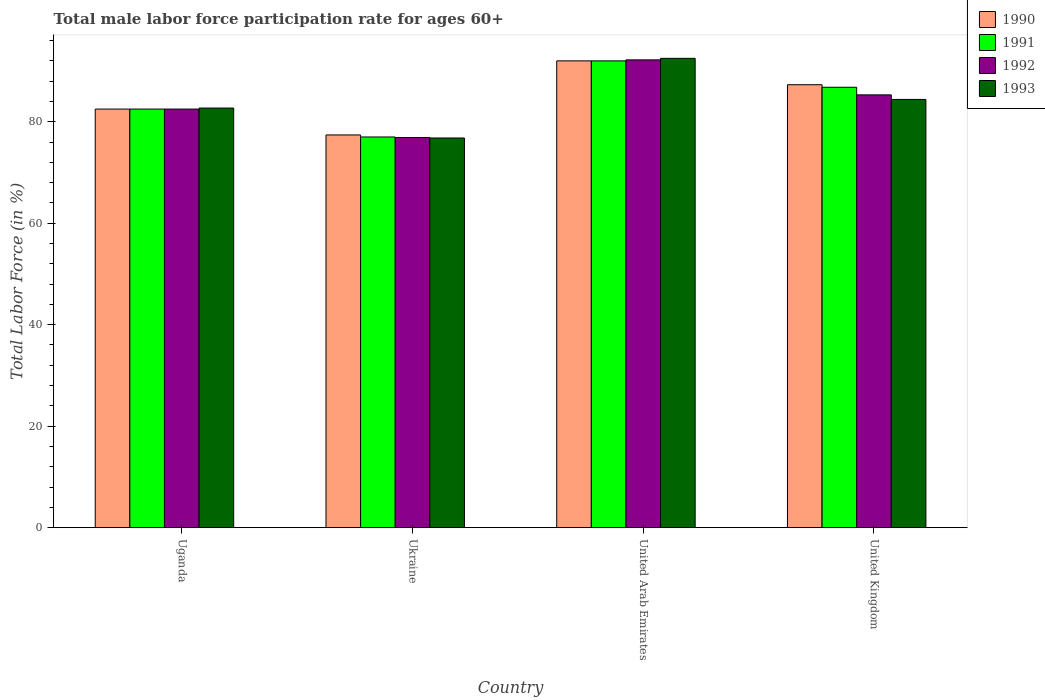How many different coloured bars are there?
Your answer should be very brief. 4. How many groups of bars are there?
Make the answer very short. 4. Are the number of bars per tick equal to the number of legend labels?
Your response must be concise. Yes. Are the number of bars on each tick of the X-axis equal?
Keep it short and to the point. Yes. How many bars are there on the 1st tick from the left?
Offer a terse response. 4. What is the label of the 2nd group of bars from the left?
Offer a terse response. Ukraine. What is the male labor force participation rate in 1992 in United Kingdom?
Your answer should be compact. 85.3. Across all countries, what is the maximum male labor force participation rate in 1992?
Make the answer very short. 92.2. Across all countries, what is the minimum male labor force participation rate in 1992?
Keep it short and to the point. 76.9. In which country was the male labor force participation rate in 1993 maximum?
Ensure brevity in your answer.  United Arab Emirates. In which country was the male labor force participation rate in 1991 minimum?
Ensure brevity in your answer.  Ukraine. What is the total male labor force participation rate in 1992 in the graph?
Make the answer very short. 336.9. What is the difference between the male labor force participation rate in 1991 in Uganda and that in United Kingdom?
Offer a terse response. -4.3. What is the difference between the male labor force participation rate in 1990 in Uganda and the male labor force participation rate in 1993 in United Kingdom?
Give a very brief answer. -1.9. What is the average male labor force participation rate in 1991 per country?
Your answer should be compact. 84.58. What is the difference between the male labor force participation rate of/in 1990 and male labor force participation rate of/in 1993 in Uganda?
Offer a very short reply. -0.2. What is the ratio of the male labor force participation rate in 1990 in Ukraine to that in United Kingdom?
Your answer should be very brief. 0.89. Is the male labor force participation rate in 1991 in Ukraine less than that in United Arab Emirates?
Make the answer very short. Yes. Is the difference between the male labor force participation rate in 1990 in Ukraine and United Kingdom greater than the difference between the male labor force participation rate in 1993 in Ukraine and United Kingdom?
Your response must be concise. No. What is the difference between the highest and the second highest male labor force participation rate in 1992?
Your response must be concise. -9.7. What is the difference between the highest and the lowest male labor force participation rate in 1991?
Give a very brief answer. 15. Is it the case that in every country, the sum of the male labor force participation rate in 1990 and male labor force participation rate in 1991 is greater than the sum of male labor force participation rate in 1993 and male labor force participation rate in 1992?
Provide a short and direct response. No. What does the 4th bar from the left in Ukraine represents?
Make the answer very short. 1993. Is it the case that in every country, the sum of the male labor force participation rate in 1993 and male labor force participation rate in 1990 is greater than the male labor force participation rate in 1991?
Give a very brief answer. Yes. Are all the bars in the graph horizontal?
Your answer should be compact. No. What is the difference between two consecutive major ticks on the Y-axis?
Offer a very short reply. 20. How many legend labels are there?
Your answer should be very brief. 4. How are the legend labels stacked?
Your response must be concise. Vertical. What is the title of the graph?
Offer a terse response. Total male labor force participation rate for ages 60+. Does "1996" appear as one of the legend labels in the graph?
Provide a succinct answer. No. What is the label or title of the X-axis?
Offer a terse response. Country. What is the Total Labor Force (in %) in 1990 in Uganda?
Make the answer very short. 82.5. What is the Total Labor Force (in %) of 1991 in Uganda?
Keep it short and to the point. 82.5. What is the Total Labor Force (in %) of 1992 in Uganda?
Make the answer very short. 82.5. What is the Total Labor Force (in %) of 1993 in Uganda?
Your answer should be compact. 82.7. What is the Total Labor Force (in %) in 1990 in Ukraine?
Offer a terse response. 77.4. What is the Total Labor Force (in %) of 1991 in Ukraine?
Your answer should be very brief. 77. What is the Total Labor Force (in %) in 1992 in Ukraine?
Provide a succinct answer. 76.9. What is the Total Labor Force (in %) in 1993 in Ukraine?
Your answer should be compact. 76.8. What is the Total Labor Force (in %) in 1990 in United Arab Emirates?
Give a very brief answer. 92. What is the Total Labor Force (in %) of 1991 in United Arab Emirates?
Your answer should be very brief. 92. What is the Total Labor Force (in %) in 1992 in United Arab Emirates?
Ensure brevity in your answer.  92.2. What is the Total Labor Force (in %) in 1993 in United Arab Emirates?
Ensure brevity in your answer.  92.5. What is the Total Labor Force (in %) in 1990 in United Kingdom?
Your response must be concise. 87.3. What is the Total Labor Force (in %) of 1991 in United Kingdom?
Ensure brevity in your answer.  86.8. What is the Total Labor Force (in %) in 1992 in United Kingdom?
Provide a succinct answer. 85.3. What is the Total Labor Force (in %) of 1993 in United Kingdom?
Provide a succinct answer. 84.4. Across all countries, what is the maximum Total Labor Force (in %) of 1990?
Keep it short and to the point. 92. Across all countries, what is the maximum Total Labor Force (in %) of 1991?
Your answer should be compact. 92. Across all countries, what is the maximum Total Labor Force (in %) in 1992?
Ensure brevity in your answer.  92.2. Across all countries, what is the maximum Total Labor Force (in %) in 1993?
Your answer should be very brief. 92.5. Across all countries, what is the minimum Total Labor Force (in %) of 1990?
Make the answer very short. 77.4. Across all countries, what is the minimum Total Labor Force (in %) of 1992?
Your answer should be very brief. 76.9. Across all countries, what is the minimum Total Labor Force (in %) in 1993?
Your response must be concise. 76.8. What is the total Total Labor Force (in %) in 1990 in the graph?
Offer a terse response. 339.2. What is the total Total Labor Force (in %) of 1991 in the graph?
Provide a succinct answer. 338.3. What is the total Total Labor Force (in %) of 1992 in the graph?
Provide a short and direct response. 336.9. What is the total Total Labor Force (in %) in 1993 in the graph?
Your answer should be compact. 336.4. What is the difference between the Total Labor Force (in %) of 1990 in Uganda and that in Ukraine?
Your response must be concise. 5.1. What is the difference between the Total Labor Force (in %) in 1991 in Uganda and that in Ukraine?
Keep it short and to the point. 5.5. What is the difference between the Total Labor Force (in %) of 1992 in Uganda and that in Ukraine?
Offer a very short reply. 5.6. What is the difference between the Total Labor Force (in %) of 1991 in Uganda and that in United Arab Emirates?
Your answer should be very brief. -9.5. What is the difference between the Total Labor Force (in %) of 1992 in Uganda and that in United Kingdom?
Make the answer very short. -2.8. What is the difference between the Total Labor Force (in %) in 1990 in Ukraine and that in United Arab Emirates?
Ensure brevity in your answer.  -14.6. What is the difference between the Total Labor Force (in %) in 1991 in Ukraine and that in United Arab Emirates?
Ensure brevity in your answer.  -15. What is the difference between the Total Labor Force (in %) in 1992 in Ukraine and that in United Arab Emirates?
Make the answer very short. -15.3. What is the difference between the Total Labor Force (in %) of 1993 in Ukraine and that in United Arab Emirates?
Keep it short and to the point. -15.7. What is the difference between the Total Labor Force (in %) of 1992 in Ukraine and that in United Kingdom?
Your response must be concise. -8.4. What is the difference between the Total Labor Force (in %) of 1990 in United Arab Emirates and that in United Kingdom?
Ensure brevity in your answer.  4.7. What is the difference between the Total Labor Force (in %) in 1991 in United Arab Emirates and that in United Kingdom?
Provide a short and direct response. 5.2. What is the difference between the Total Labor Force (in %) of 1993 in United Arab Emirates and that in United Kingdom?
Your response must be concise. 8.1. What is the difference between the Total Labor Force (in %) in 1990 in Uganda and the Total Labor Force (in %) in 1991 in Ukraine?
Your response must be concise. 5.5. What is the difference between the Total Labor Force (in %) in 1991 in Uganda and the Total Labor Force (in %) in 1993 in Ukraine?
Provide a short and direct response. 5.7. What is the difference between the Total Labor Force (in %) in 1992 in Uganda and the Total Labor Force (in %) in 1993 in Ukraine?
Your answer should be compact. 5.7. What is the difference between the Total Labor Force (in %) in 1990 in Uganda and the Total Labor Force (in %) in 1991 in United Arab Emirates?
Provide a succinct answer. -9.5. What is the difference between the Total Labor Force (in %) in 1990 in Uganda and the Total Labor Force (in %) in 1993 in United Arab Emirates?
Provide a short and direct response. -10. What is the difference between the Total Labor Force (in %) of 1991 in Uganda and the Total Labor Force (in %) of 1992 in United Arab Emirates?
Provide a short and direct response. -9.7. What is the difference between the Total Labor Force (in %) in 1990 in Uganda and the Total Labor Force (in %) in 1991 in United Kingdom?
Offer a terse response. -4.3. What is the difference between the Total Labor Force (in %) in 1990 in Uganda and the Total Labor Force (in %) in 1992 in United Kingdom?
Give a very brief answer. -2.8. What is the difference between the Total Labor Force (in %) of 1990 in Uganda and the Total Labor Force (in %) of 1993 in United Kingdom?
Your answer should be compact. -1.9. What is the difference between the Total Labor Force (in %) in 1991 in Uganda and the Total Labor Force (in %) in 1992 in United Kingdom?
Give a very brief answer. -2.8. What is the difference between the Total Labor Force (in %) of 1992 in Uganda and the Total Labor Force (in %) of 1993 in United Kingdom?
Offer a terse response. -1.9. What is the difference between the Total Labor Force (in %) of 1990 in Ukraine and the Total Labor Force (in %) of 1991 in United Arab Emirates?
Your answer should be very brief. -14.6. What is the difference between the Total Labor Force (in %) of 1990 in Ukraine and the Total Labor Force (in %) of 1992 in United Arab Emirates?
Ensure brevity in your answer.  -14.8. What is the difference between the Total Labor Force (in %) in 1990 in Ukraine and the Total Labor Force (in %) in 1993 in United Arab Emirates?
Your answer should be very brief. -15.1. What is the difference between the Total Labor Force (in %) in 1991 in Ukraine and the Total Labor Force (in %) in 1992 in United Arab Emirates?
Your answer should be very brief. -15.2. What is the difference between the Total Labor Force (in %) of 1991 in Ukraine and the Total Labor Force (in %) of 1993 in United Arab Emirates?
Your answer should be compact. -15.5. What is the difference between the Total Labor Force (in %) in 1992 in Ukraine and the Total Labor Force (in %) in 1993 in United Arab Emirates?
Provide a short and direct response. -15.6. What is the difference between the Total Labor Force (in %) of 1990 in Ukraine and the Total Labor Force (in %) of 1991 in United Kingdom?
Offer a very short reply. -9.4. What is the difference between the Total Labor Force (in %) in 1991 in Ukraine and the Total Labor Force (in %) in 1992 in United Kingdom?
Your answer should be compact. -8.3. What is the difference between the Total Labor Force (in %) of 1991 in Ukraine and the Total Labor Force (in %) of 1993 in United Kingdom?
Your answer should be compact. -7.4. What is the difference between the Total Labor Force (in %) of 1990 in United Arab Emirates and the Total Labor Force (in %) of 1991 in United Kingdom?
Your response must be concise. 5.2. What is the difference between the Total Labor Force (in %) in 1990 in United Arab Emirates and the Total Labor Force (in %) in 1993 in United Kingdom?
Provide a short and direct response. 7.6. What is the difference between the Total Labor Force (in %) in 1991 in United Arab Emirates and the Total Labor Force (in %) in 1992 in United Kingdom?
Your answer should be compact. 6.7. What is the difference between the Total Labor Force (in %) of 1992 in United Arab Emirates and the Total Labor Force (in %) of 1993 in United Kingdom?
Your answer should be compact. 7.8. What is the average Total Labor Force (in %) in 1990 per country?
Your answer should be very brief. 84.8. What is the average Total Labor Force (in %) of 1991 per country?
Provide a succinct answer. 84.58. What is the average Total Labor Force (in %) in 1992 per country?
Provide a succinct answer. 84.22. What is the average Total Labor Force (in %) of 1993 per country?
Offer a terse response. 84.1. What is the difference between the Total Labor Force (in %) of 1990 and Total Labor Force (in %) of 1991 in Uganda?
Make the answer very short. 0. What is the difference between the Total Labor Force (in %) in 1990 and Total Labor Force (in %) in 1992 in Uganda?
Your answer should be very brief. 0. What is the difference between the Total Labor Force (in %) in 1990 and Total Labor Force (in %) in 1993 in Uganda?
Provide a succinct answer. -0.2. What is the difference between the Total Labor Force (in %) in 1991 and Total Labor Force (in %) in 1992 in Uganda?
Provide a short and direct response. 0. What is the difference between the Total Labor Force (in %) of 1991 and Total Labor Force (in %) of 1993 in Uganda?
Make the answer very short. -0.2. What is the difference between the Total Labor Force (in %) of 1990 and Total Labor Force (in %) of 1992 in Ukraine?
Provide a short and direct response. 0.5. What is the difference between the Total Labor Force (in %) of 1991 and Total Labor Force (in %) of 1992 in Ukraine?
Your response must be concise. 0.1. What is the difference between the Total Labor Force (in %) in 1991 and Total Labor Force (in %) in 1993 in Ukraine?
Provide a succinct answer. 0.2. What is the difference between the Total Labor Force (in %) of 1990 and Total Labor Force (in %) of 1993 in United Arab Emirates?
Make the answer very short. -0.5. What is the difference between the Total Labor Force (in %) of 1990 and Total Labor Force (in %) of 1993 in United Kingdom?
Your answer should be compact. 2.9. What is the difference between the Total Labor Force (in %) in 1991 and Total Labor Force (in %) in 1993 in United Kingdom?
Offer a very short reply. 2.4. What is the ratio of the Total Labor Force (in %) of 1990 in Uganda to that in Ukraine?
Your answer should be compact. 1.07. What is the ratio of the Total Labor Force (in %) in 1991 in Uganda to that in Ukraine?
Give a very brief answer. 1.07. What is the ratio of the Total Labor Force (in %) in 1992 in Uganda to that in Ukraine?
Provide a succinct answer. 1.07. What is the ratio of the Total Labor Force (in %) in 1993 in Uganda to that in Ukraine?
Make the answer very short. 1.08. What is the ratio of the Total Labor Force (in %) of 1990 in Uganda to that in United Arab Emirates?
Your answer should be compact. 0.9. What is the ratio of the Total Labor Force (in %) of 1991 in Uganda to that in United Arab Emirates?
Make the answer very short. 0.9. What is the ratio of the Total Labor Force (in %) of 1992 in Uganda to that in United Arab Emirates?
Your answer should be compact. 0.89. What is the ratio of the Total Labor Force (in %) of 1993 in Uganda to that in United Arab Emirates?
Offer a very short reply. 0.89. What is the ratio of the Total Labor Force (in %) in 1990 in Uganda to that in United Kingdom?
Offer a terse response. 0.94. What is the ratio of the Total Labor Force (in %) in 1991 in Uganda to that in United Kingdom?
Your answer should be compact. 0.95. What is the ratio of the Total Labor Force (in %) of 1992 in Uganda to that in United Kingdom?
Your answer should be compact. 0.97. What is the ratio of the Total Labor Force (in %) in 1993 in Uganda to that in United Kingdom?
Provide a succinct answer. 0.98. What is the ratio of the Total Labor Force (in %) of 1990 in Ukraine to that in United Arab Emirates?
Offer a terse response. 0.84. What is the ratio of the Total Labor Force (in %) in 1991 in Ukraine to that in United Arab Emirates?
Your response must be concise. 0.84. What is the ratio of the Total Labor Force (in %) of 1992 in Ukraine to that in United Arab Emirates?
Ensure brevity in your answer.  0.83. What is the ratio of the Total Labor Force (in %) in 1993 in Ukraine to that in United Arab Emirates?
Your answer should be very brief. 0.83. What is the ratio of the Total Labor Force (in %) of 1990 in Ukraine to that in United Kingdom?
Your answer should be very brief. 0.89. What is the ratio of the Total Labor Force (in %) in 1991 in Ukraine to that in United Kingdom?
Give a very brief answer. 0.89. What is the ratio of the Total Labor Force (in %) in 1992 in Ukraine to that in United Kingdom?
Offer a very short reply. 0.9. What is the ratio of the Total Labor Force (in %) in 1993 in Ukraine to that in United Kingdom?
Your answer should be very brief. 0.91. What is the ratio of the Total Labor Force (in %) in 1990 in United Arab Emirates to that in United Kingdom?
Keep it short and to the point. 1.05. What is the ratio of the Total Labor Force (in %) in 1991 in United Arab Emirates to that in United Kingdom?
Ensure brevity in your answer.  1.06. What is the ratio of the Total Labor Force (in %) of 1992 in United Arab Emirates to that in United Kingdom?
Your answer should be very brief. 1.08. What is the ratio of the Total Labor Force (in %) in 1993 in United Arab Emirates to that in United Kingdom?
Give a very brief answer. 1.1. What is the difference between the highest and the second highest Total Labor Force (in %) in 1990?
Make the answer very short. 4.7. What is the difference between the highest and the lowest Total Labor Force (in %) of 1990?
Your response must be concise. 14.6. What is the difference between the highest and the lowest Total Labor Force (in %) in 1992?
Provide a succinct answer. 15.3. What is the difference between the highest and the lowest Total Labor Force (in %) in 1993?
Provide a succinct answer. 15.7. 